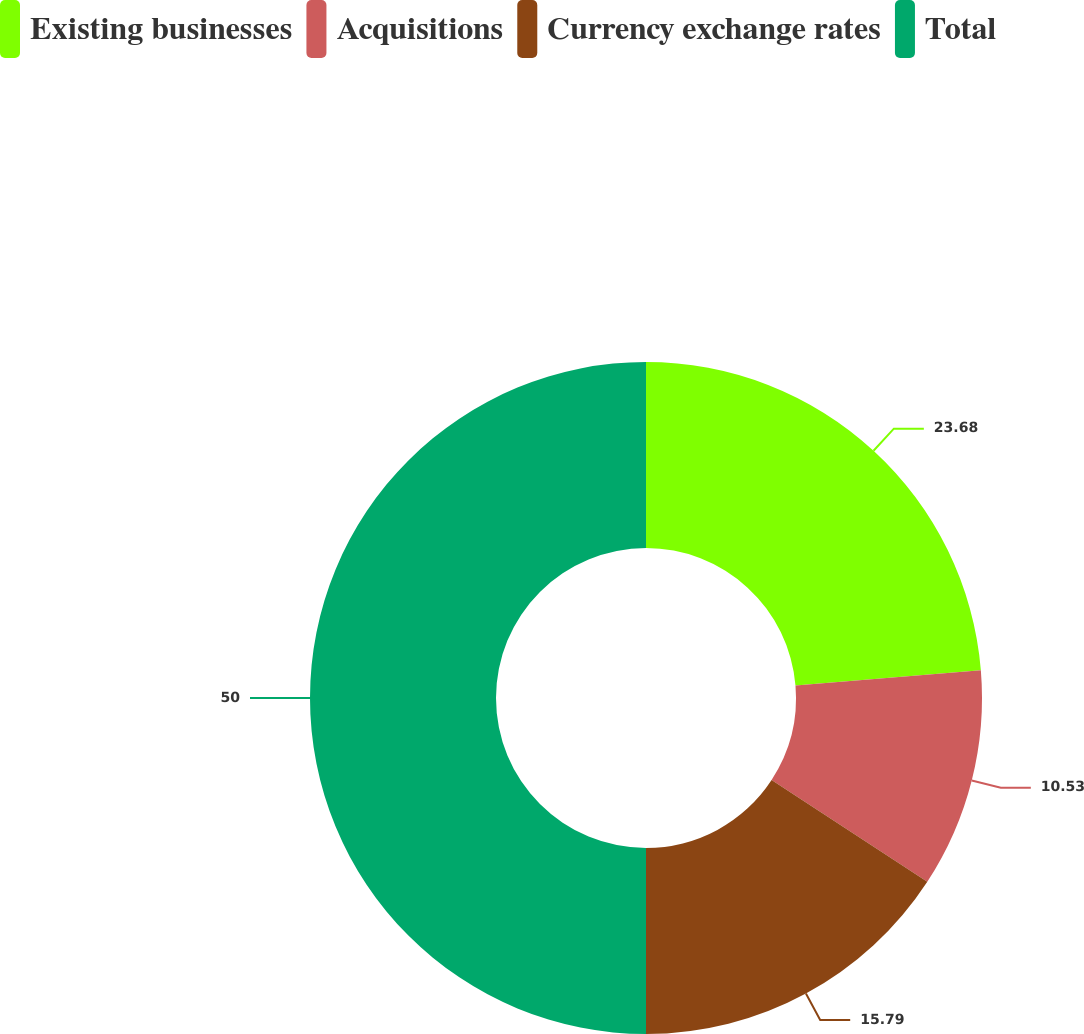Convert chart. <chart><loc_0><loc_0><loc_500><loc_500><pie_chart><fcel>Existing businesses<fcel>Acquisitions<fcel>Currency exchange rates<fcel>Total<nl><fcel>23.68%<fcel>10.53%<fcel>15.79%<fcel>50.0%<nl></chart> 